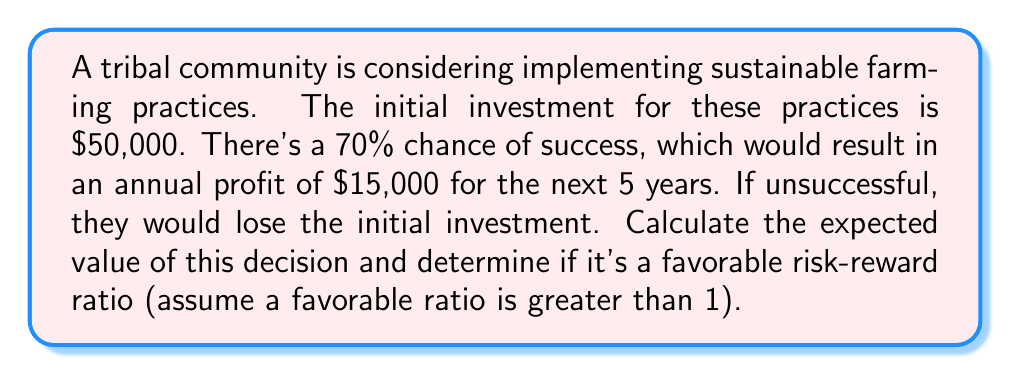Can you answer this question? To solve this problem, we need to:
1. Calculate the potential reward
2. Calculate the potential loss
3. Determine the expected value
4. Calculate the risk-reward ratio

Step 1: Calculate the potential reward
If successful, the community would earn $15,000 annually for 5 years.
Total potential reward = $15,000 × 5 = $75,000

Step 2: Calculate the potential loss
If unsuccessful, the community would lose the initial investment of $50,000.

Step 3: Determine the expected value
Let's use the formula for expected value:
$$ EV = (P_{success} \times Reward) + (P_{failure} \times Loss) $$

Where:
$P_{success} = 0.70$ (70% chance of success)
$P_{failure} = 1 - P_{success} = 0.30$ (30% chance of failure)
$Reward = \$75,000$
$Loss = -\$50,000$ (negative because it's a loss)

$$ EV = (0.70 \times \$75,000) + (0.30 \times (-\$50,000)) $$
$$ EV = \$52,500 - \$15,000 $$
$$ EV = \$37,500 $$

Step 4: Calculate the risk-reward ratio
Risk-Reward Ratio = $\frac{Potential \: Reward}{Potential \: Loss}$

$$ \text{Risk-Reward Ratio} = \frac{\$75,000}{\$50,000} = 1.5 $$

Since 1.5 > 1, this is considered a favorable risk-reward ratio.
Answer: The expected value of the decision is $37,500, and the risk-reward ratio is 1.5. This indicates a favorable risk-reward ratio for the tribal community's sustainable farming practices. 